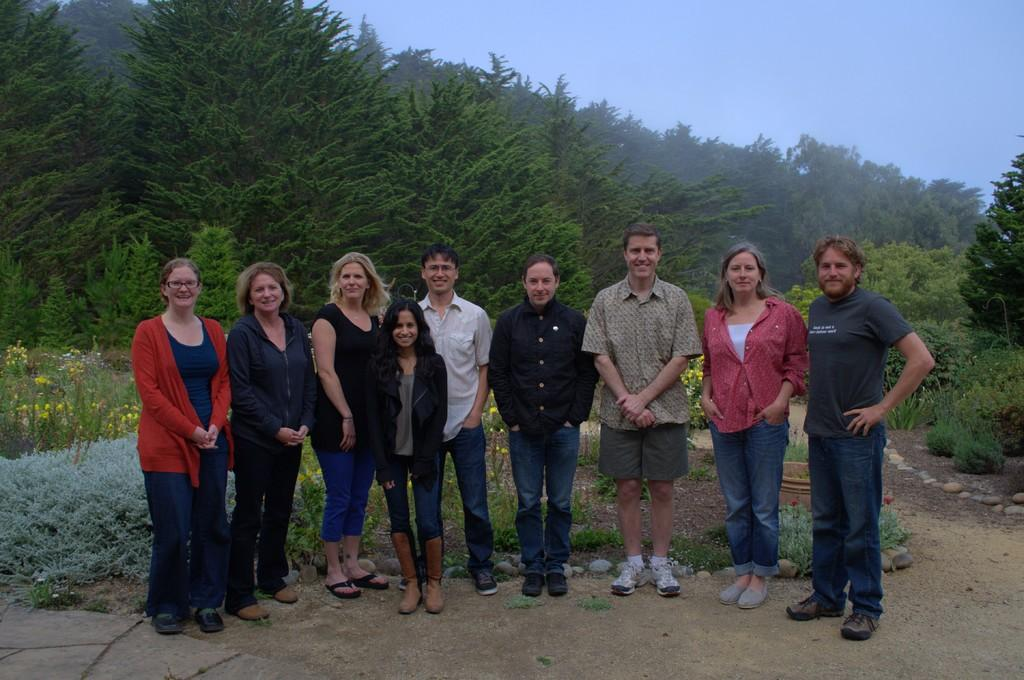What type of environment is depicted in the image? The image shows people on the grounds, which suggests an outdoor setting. What kind of vegetation can be seen in the image? There are plants, trees, and grass visible in the image. What other elements are present in the image? There are stones in the image. What can be seen in the sky in the image? The sky is visible in the image. What color is the pump in the image? There is no pump present in the image. What time of day is depicted in the image? The time of day cannot be determined from the image alone, as there are no specific clues or indicators. 